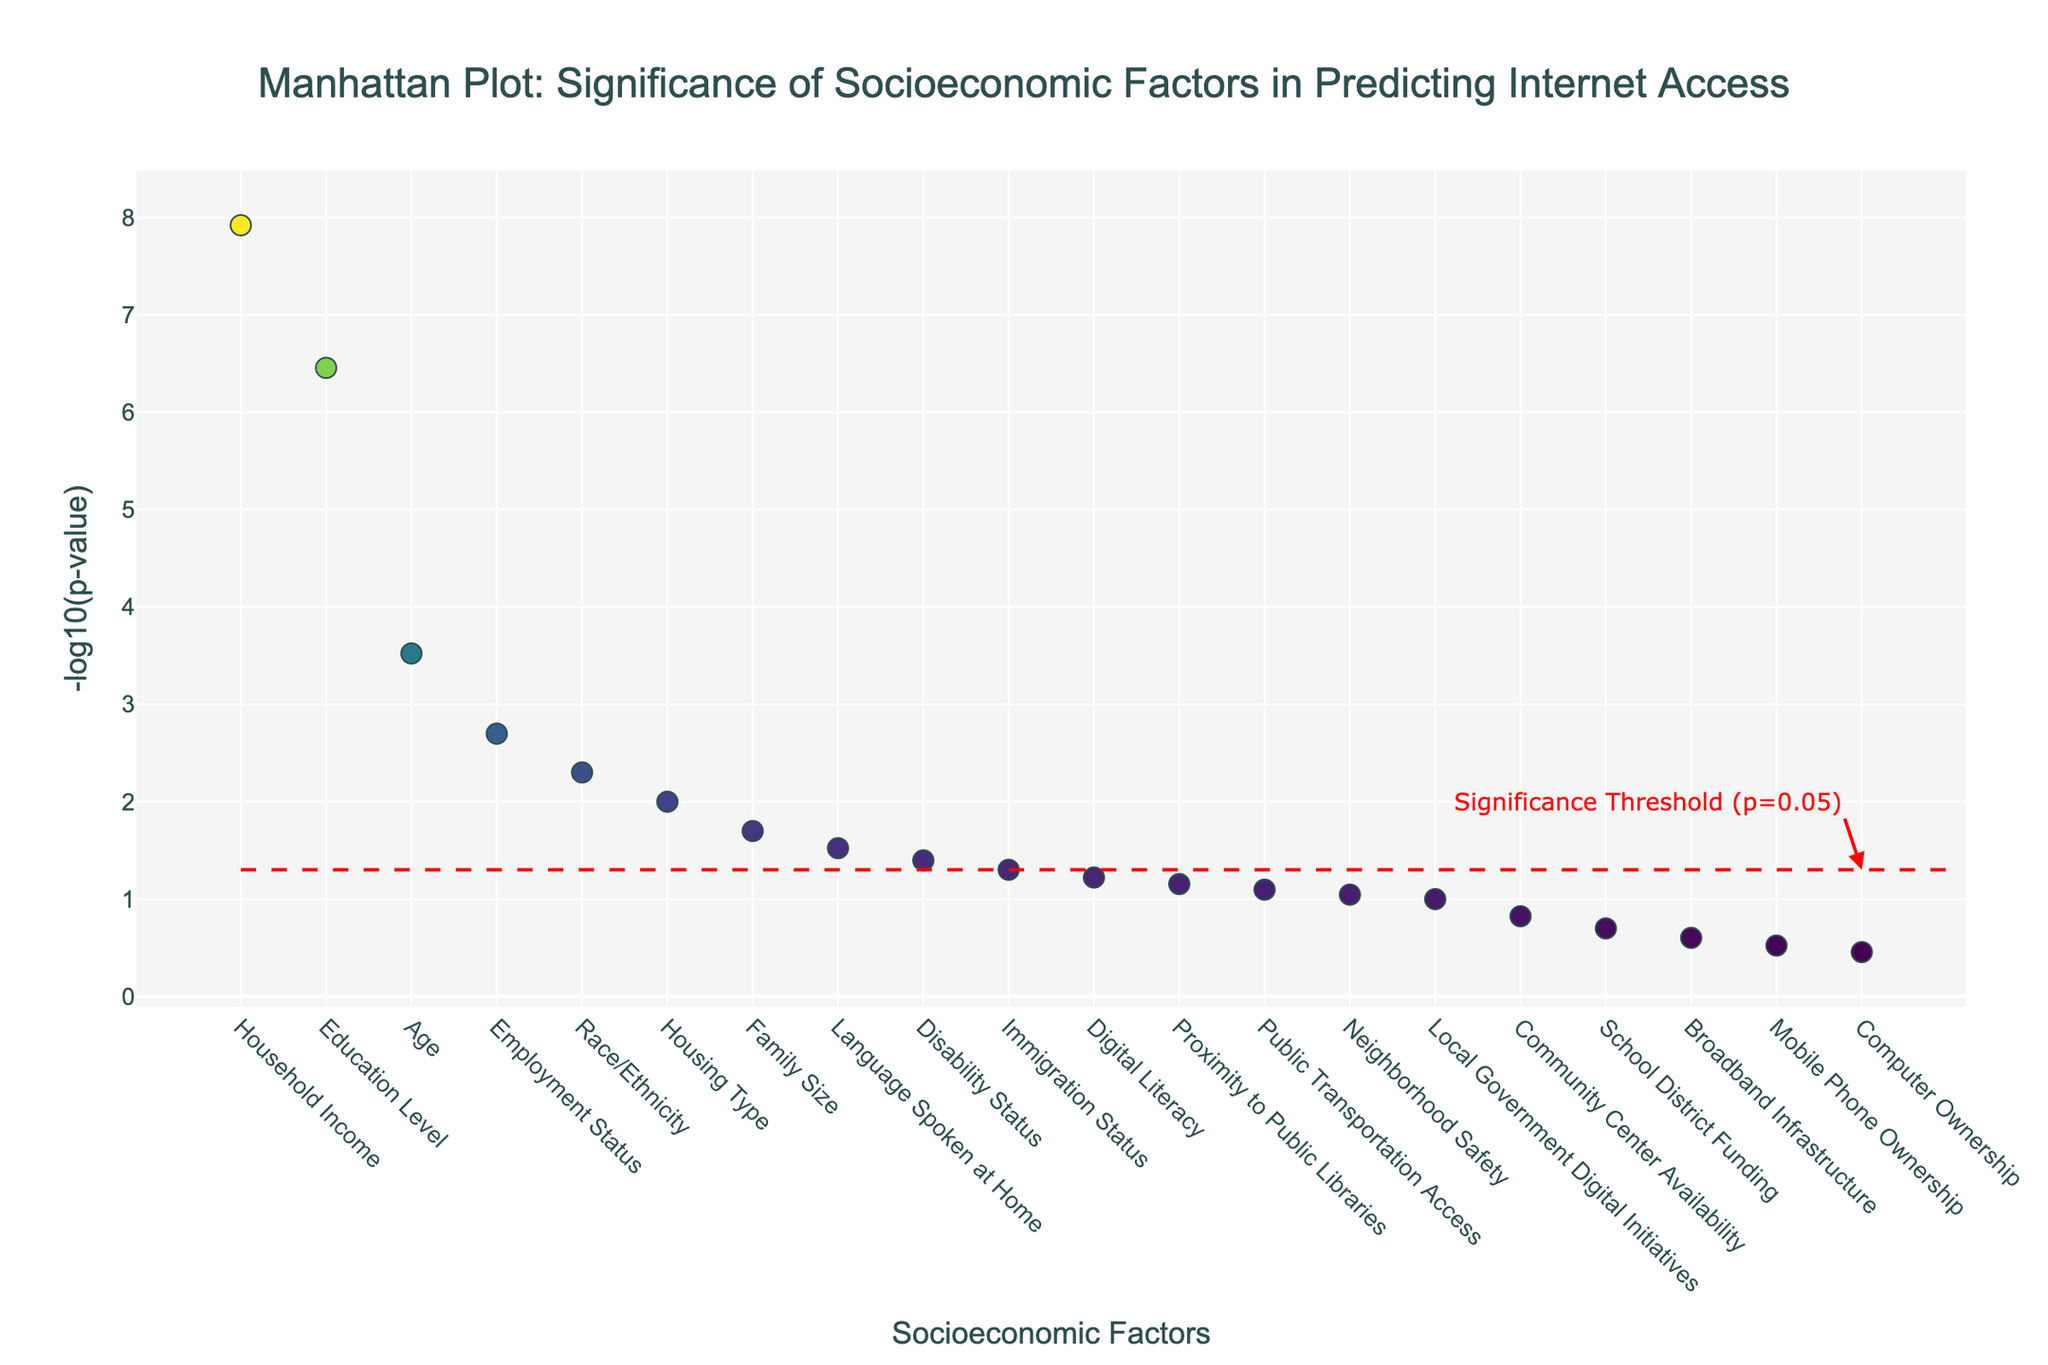How many socioeconomic factors are included in the analysis? The x-axis lists the socioeconomic factors analyzed, each represented by a data point. Counting all the unique labels on the x-axis from left to right will give the total number of factors included in the analysis.
Answer: 20 What does the y-axis represent? The y-axis is labeled as -log10(p-value), representing the negative logarithm of the p-values for each socioeconomic factor. These values indicate the statistical significance of the factors in predicting internet access.
Answer: -log10(p-value) What is the significance threshold, and how is it visually represented? The significance threshold is set at a p-value of 0.05. This is visually indicated by a horizontal dashed red line on the plot. The y-coordinate of this line is -log10(0.05), which is approximately 1.3.
Answer: -log10(0.05) or approximately 1.3 Which factor is the most significant in predicting internet access among urban neighborhoods? The most significant factor can be identified by finding the highest -log10(p-value) on the plot. It corresponds to the data point positioned the highest on the y-axis. According to the data, this is Household Income, with a -log10(p-value) of 8.92.
Answer: Household Income How many factors have a p-value less than 0.05? To determine this, identify all factors whose -log10(p-value) is above the significance threshold line (approximately 1.3). Counting these points provides the number of factors with p-values less than 0.05.
Answer: 8 Which factors fall below the significance threshold line? Factors below the significance threshold line have -log10(p-values) less than approximately 1.3. Identifying and listing the factors with lower y-values than this line provides the answer.
Answer: Broadband Infrastructure, Mobile Phone Ownership, Computer Ownership, Community Center Availability, School District Funding, Local Government Digital Initiatives, Neighborhood Safety, Public Transportation Access, Proximity to Public Libraries, Digital Literacy, Immigration Status, Disability Status, Language Spoken at Home, Family Size, Housing Type What is the -log10(p-value) of Digital Literacy, and is it above or below the significance threshold? Locate Digital Literacy on the x-axis and find its corresponding y-value. The y-coordinate gives the -log10(p-value), and comparing this y-value to the threshold line at approximately 1.3 determines if it is above or below the threshold.
Answer: -log10(p-value) of 1.22, below threshold Compare the significance of Education Level and Race/Ethnicity. Which is more significant? Find the -log10(p-values) for both Education Level and Race/Ethnicity on the plot. The factor with a higher -log10(p-value) is more significant.
Answer: Education Level is more significant What are the two least significant factors in the analysis? Locate the two smallest -log10(p-values) on the y-axis. These correspond to the data points positioned lowest on the plot, which are Mobile Phone Ownership and Computer Ownership.
Answer: Mobile Phone Ownership, Computer Ownership 